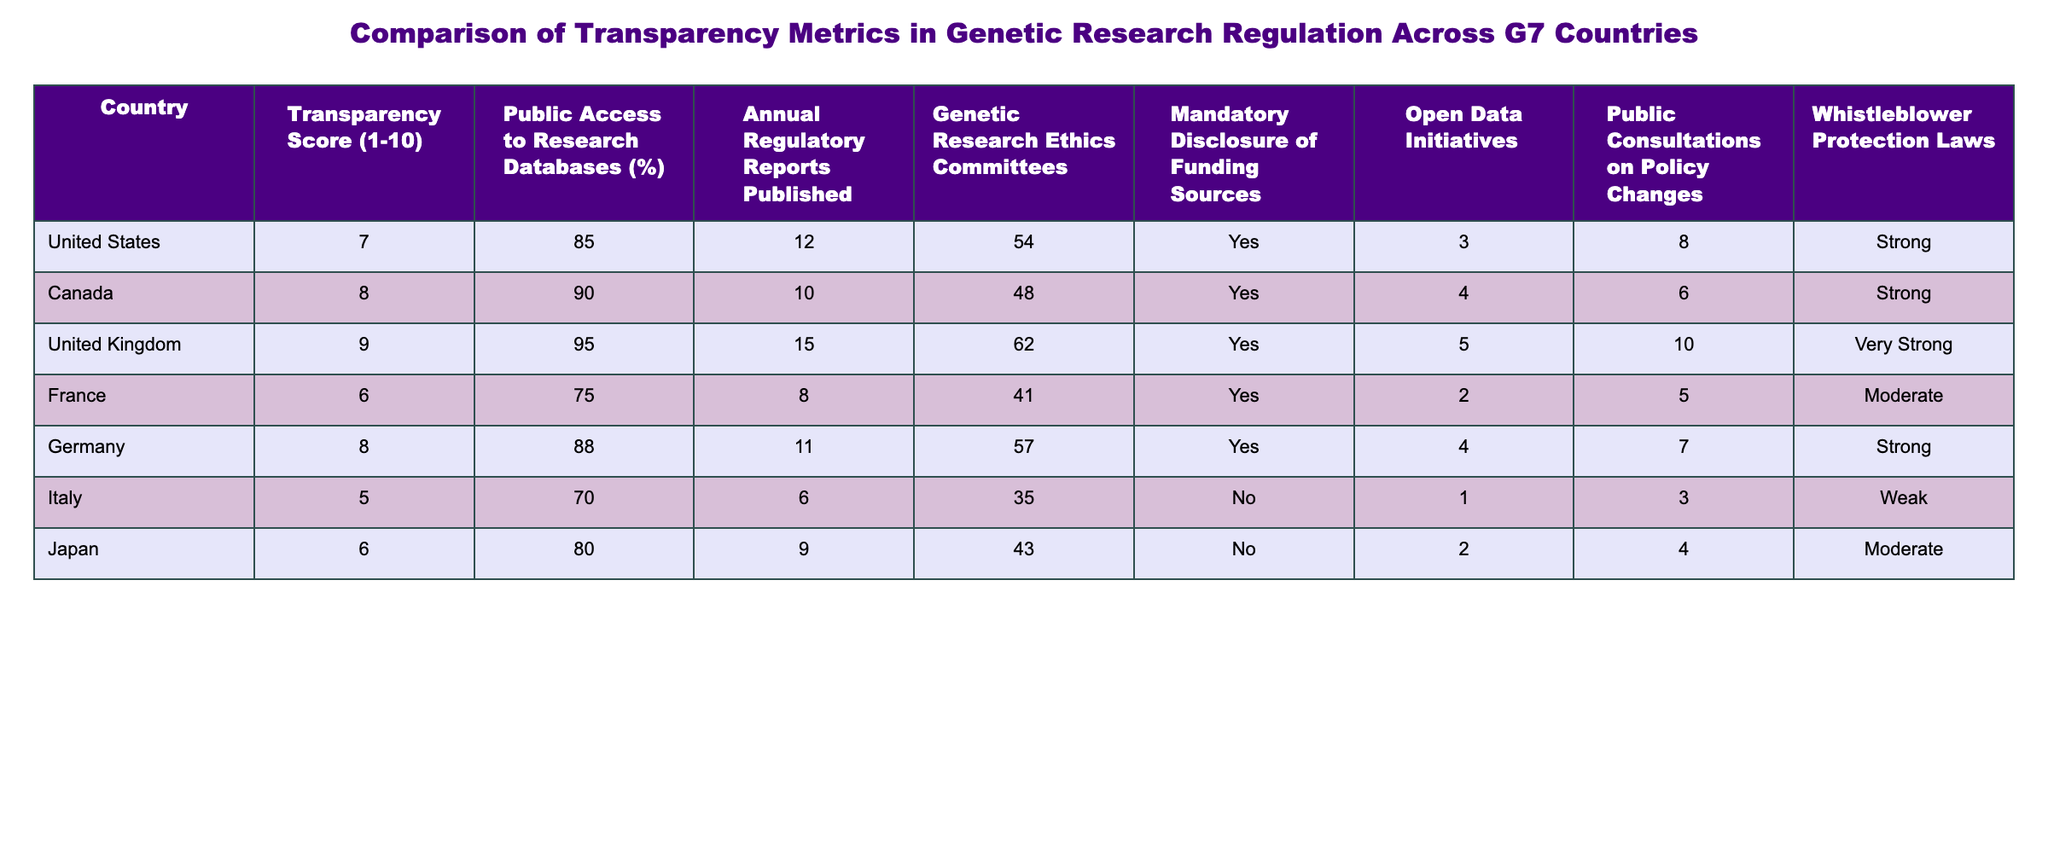What is the transparency score of the United States? The transparency score for the United States is provided directly in the table under the "Transparency Score (1-10)" column. It is listed as 7.
Answer: 7 Which country has the highest percentage of public access to research databases? In the table, the country with the highest percentage of public access to research databases is the United Kingdom, which is at 95%.
Answer: 95% How many annual regulatory reports are published by Canada? The number of annual regulatory reports published by Canada is directly stated in the table as 10.
Answer: 10 Which G7 country reported not having mandatory disclosure of funding sources? In the table, Italy and Japan are the only countries listed with 'No' under the "Mandatory Disclosure of Funding Sources" column.
Answer: Italy and Japan What is the average transparency score of G7 countries listed in the table? To calculate the average transparency score, add the scores: (7 + 8 + 9 + 6 + 8 + 5 + 6) = 49. There are 7 countries, so the average is 49/7 = 7.
Answer: 7 Which country has the most robust whistleblower protection laws? By comparing the "Whistleblower Protection Laws" column, the United Kingdom has the most robust classification, marked as "Very Strong."
Answer: Very Strong Is there a correlation between the percentage of public access to research databases and the transparency score in G7 countries? To determine this, look at the transparency scores and access percentages. The scores are (7, 8, 9, 6, 8, 5, 6) corresponding to access percentages (85, 90, 95, 75, 88, 70, 80). Generally, higher scores correspond to higher percent access, indicating a positive correlation.
Answer: Yes Which country has both the lowest transparency score and the lowest percentage of public access to research databases? By examining the lowest values in the table, Italy has the lowest transparency score of 5 and the lowest percentage of public access at 70%.
Answer: Italy How many countries have an annual regulatory report publication count greater than 10? By inspecting the "Annual Regulatory Reports Published" column, 3 countries (United Kingdom, Germany, and the United States) have more than 10 reports.
Answer: 3 What proportion of G7 countries have open data initiatives? There are 7 G7 countries listed, and according to the table, 5 countries have open data initiatives marked as 'Yes.' The proportion is 5/7 which simplifies to approximately 71%.
Answer: Approximately 71% Which country has the strongest mechanisms for public consultations on policy changes? By looking into the "Public Consultations on Policy Changes" column, the United Kingdom scores the highest with a count of 10.
Answer: United Kingdom 